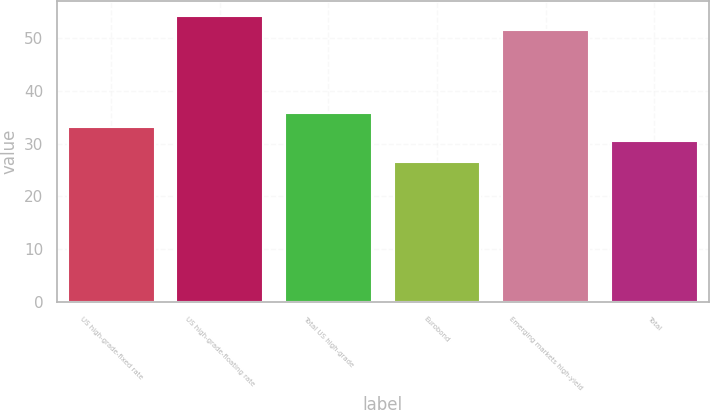<chart> <loc_0><loc_0><loc_500><loc_500><bar_chart><fcel>US high-grade-fixed rate<fcel>US high-grade-floating rate<fcel>Total US high-grade<fcel>Eurobond<fcel>Emerging markets high-yield<fcel>Total<nl><fcel>33.18<fcel>54.18<fcel>35.86<fcel>26.5<fcel>51.5<fcel>30.5<nl></chart> 